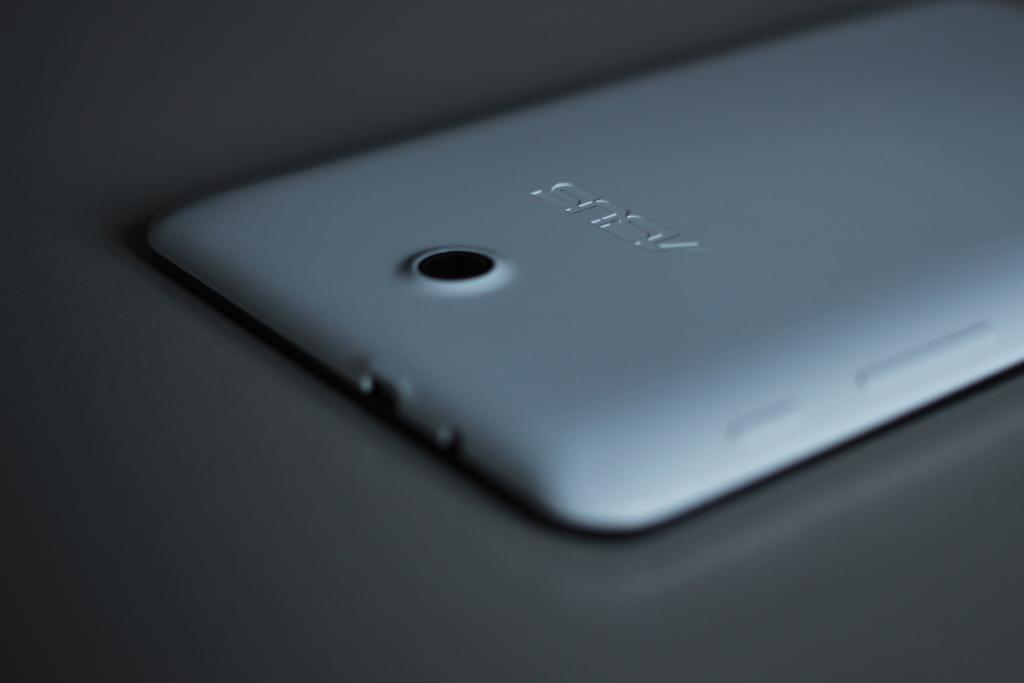Does asus make a reliable phone?
Offer a very short reply. Yes. 